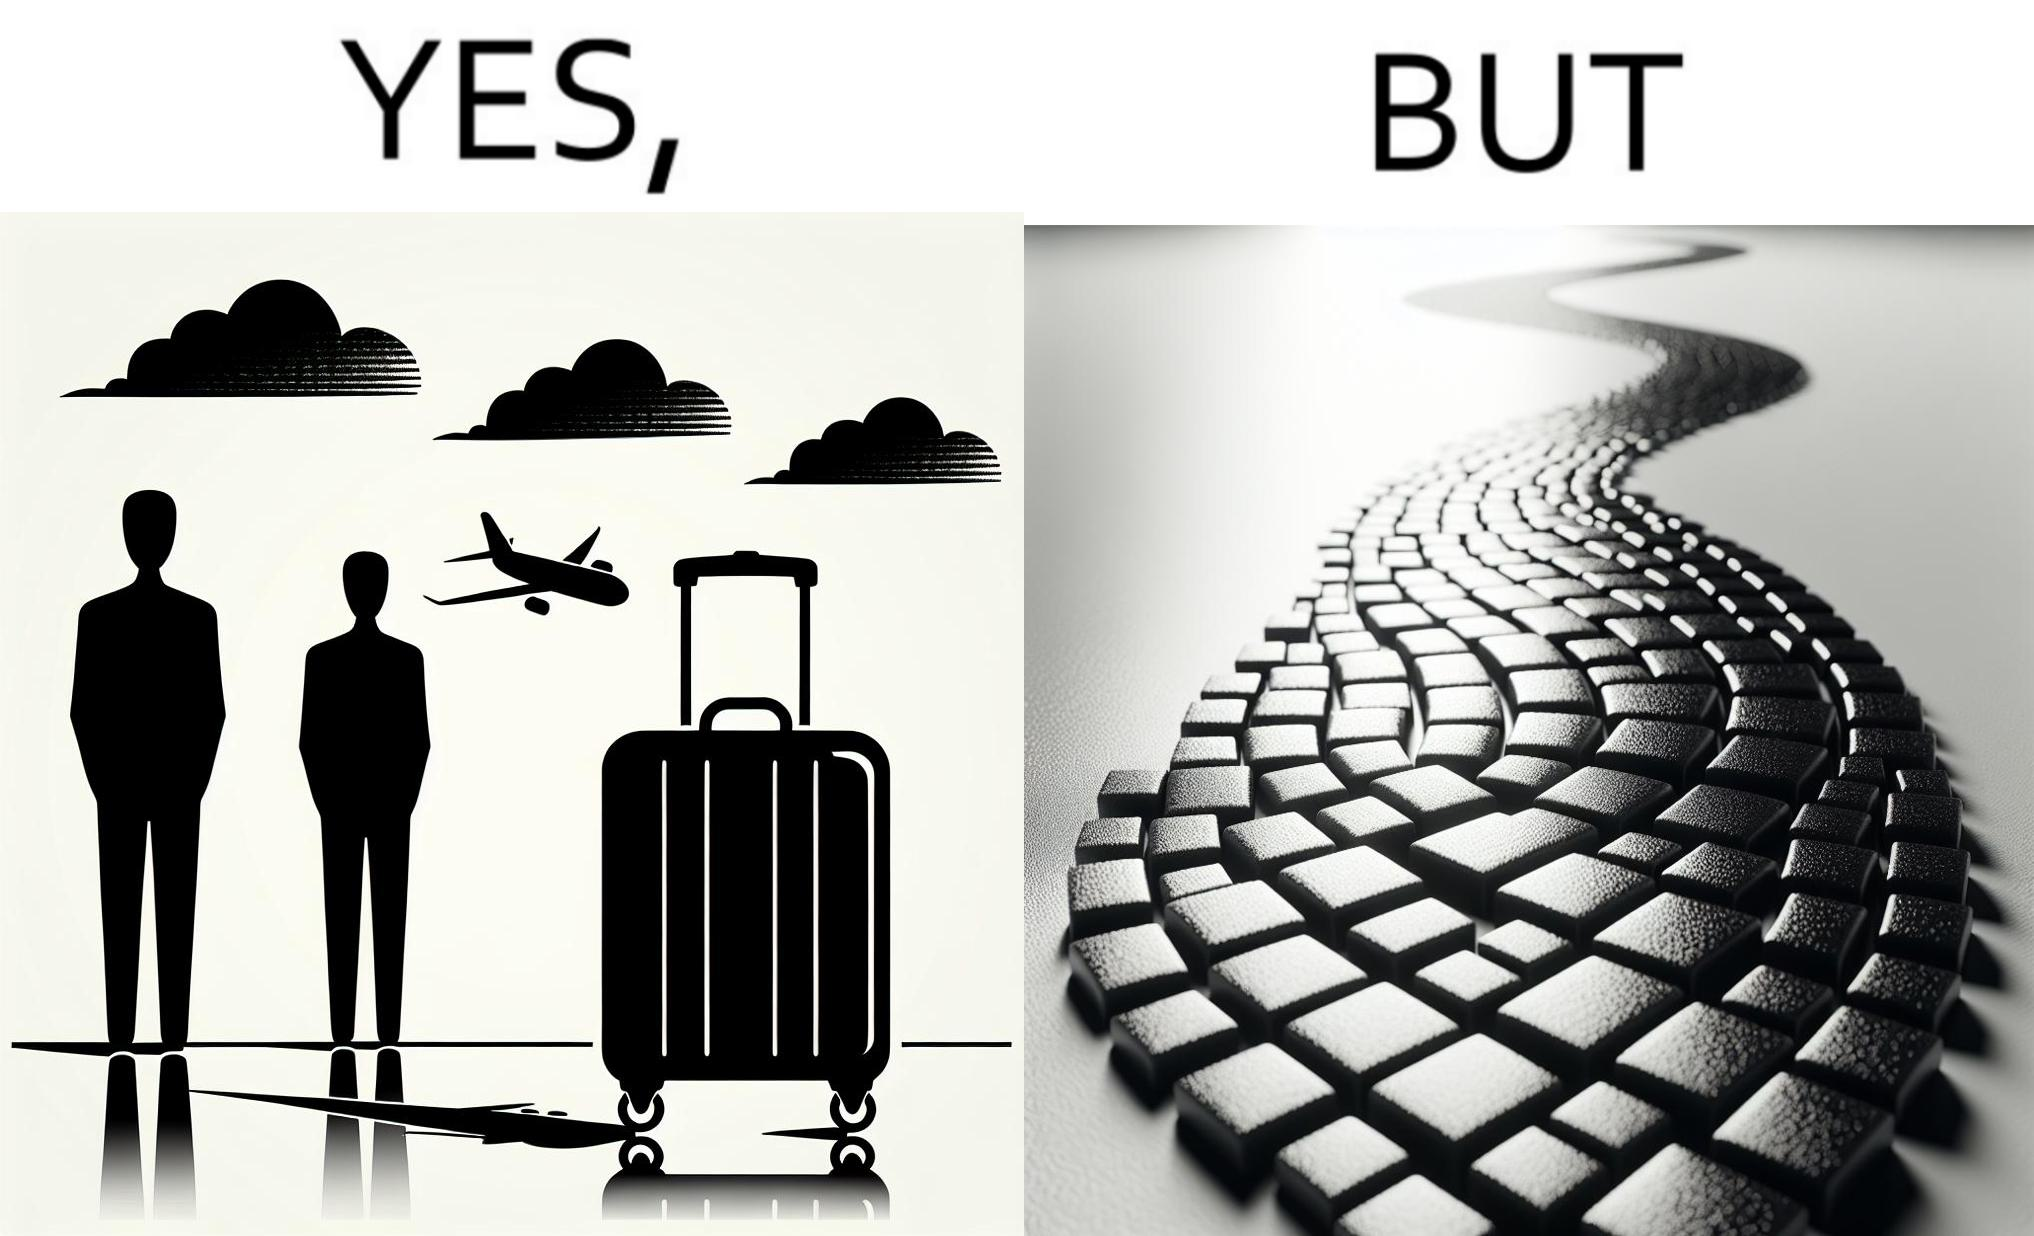What makes this image funny or satirical? The image is funny because even though the trolley bag is made to make carrying luggage easy, as soon as it encounters a rough surface like cobblestone road, it makes carrying luggage more difficult. 